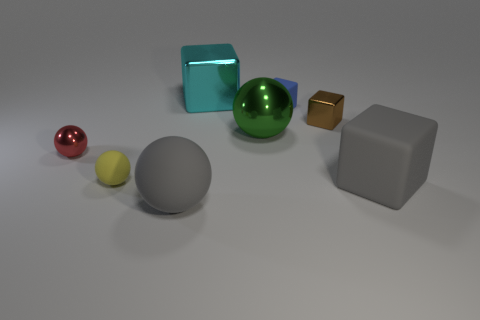Are the gray object that is on the left side of the blue matte object and the yellow object made of the same material?
Ensure brevity in your answer.  Yes. What number of objects are yellow balls or big metal things behind the green thing?
Ensure brevity in your answer.  2. How many tiny yellow balls are in front of the small rubber thing to the right of the big ball that is in front of the tiny red object?
Offer a very short reply. 1. Do the small object in front of the tiny red shiny thing and the cyan thing have the same shape?
Your answer should be very brief. No. Are there any shiny spheres right of the tiny rubber object in front of the red object?
Offer a terse response. Yes. How many tiny red metallic objects are there?
Your response must be concise. 1. There is a small thing that is in front of the small brown thing and behind the yellow thing; what is its color?
Your answer should be compact. Red. What is the size of the gray rubber object that is the same shape as the big green metallic thing?
Keep it short and to the point. Large. How many red metal spheres are the same size as the brown metal block?
Make the answer very short. 1. What is the large cyan block made of?
Offer a terse response. Metal. 